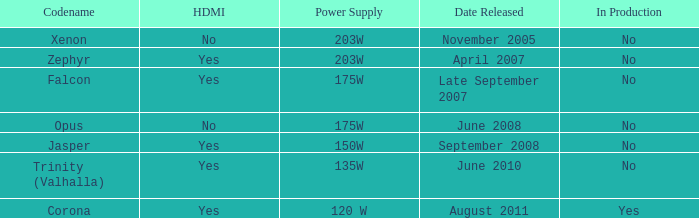Does Trinity (valhalla) have HDMI? Yes. 